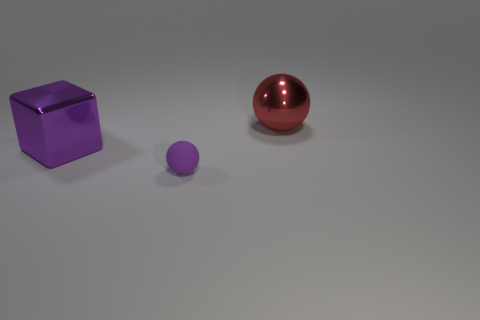Subtract all purple spheres. How many spheres are left? 1 Subtract all spheres. How many objects are left? 1 Add 3 big red objects. How many objects exist? 6 Subtract 1 purple spheres. How many objects are left? 2 Subtract 1 balls. How many balls are left? 1 Subtract all blue spheres. Subtract all blue cylinders. How many spheres are left? 2 Subtract all purple blocks. How many gray spheres are left? 0 Subtract all tiny brown objects. Subtract all balls. How many objects are left? 1 Add 1 big red shiny spheres. How many big red shiny spheres are left? 2 Add 3 yellow matte blocks. How many yellow matte blocks exist? 3 